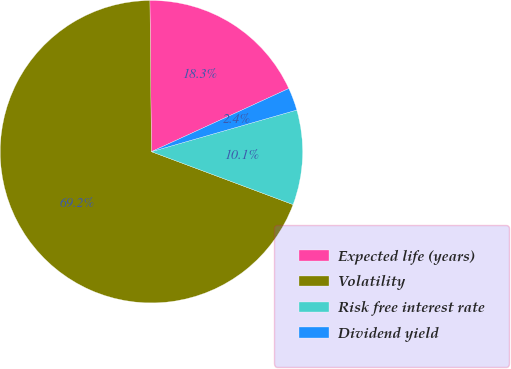<chart> <loc_0><loc_0><loc_500><loc_500><pie_chart><fcel>Expected life (years)<fcel>Volatility<fcel>Risk free interest rate<fcel>Dividend yield<nl><fcel>18.3%<fcel>69.15%<fcel>10.13%<fcel>2.42%<nl></chart> 